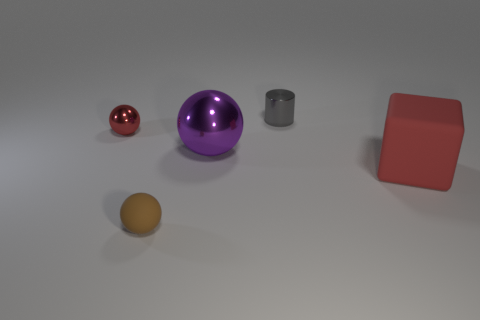What textures are present on the objects, and does each object seem to reflect light differently? The objects exhibit varied textures; the spheres and the cylinder have smooth surfaces indicative of a metallic finish. This grants them reflective properties, with the red sphere and purple sphere showing clear highlights and evidence of a glossy sheen. The red cube and the yellow ellipsoid have matte finishes with less pronounced reflections. The difference in texture and reflectivity adds an element of contrast to the scene. If these objects were placed in an outdoor setting, how might natural elements affect their appearance? In an outdoor setting, natural elements would greatly influence their appearance. Direct sunlight could enhance the reflectivity of the metallic objects, creating stronger highlights and possibly overexposed areas on the surfaces. Additionally, factors such as wind could stir up dust that might settle on the objects, altering their perceived color and texture. If exposed to rain, the objects could exhibit water droplets that would also impact how they reflect light, with the potential for interesting sparkle effects on the metallic surfaces. 